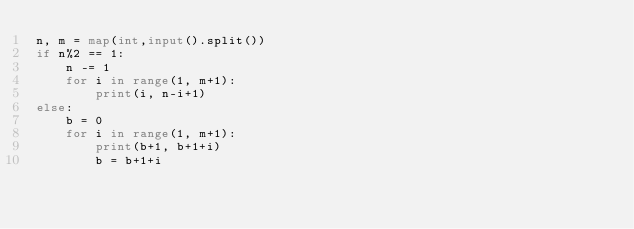Convert code to text. <code><loc_0><loc_0><loc_500><loc_500><_Python_>n, m = map(int,input().split())
if n%2 == 1:
    n -= 1
    for i in range(1, m+1):
        print(i, n-i+1)
else:
    b = 0
    for i in range(1, m+1):
        print(b+1, b+1+i)
        b = b+1+i</code> 